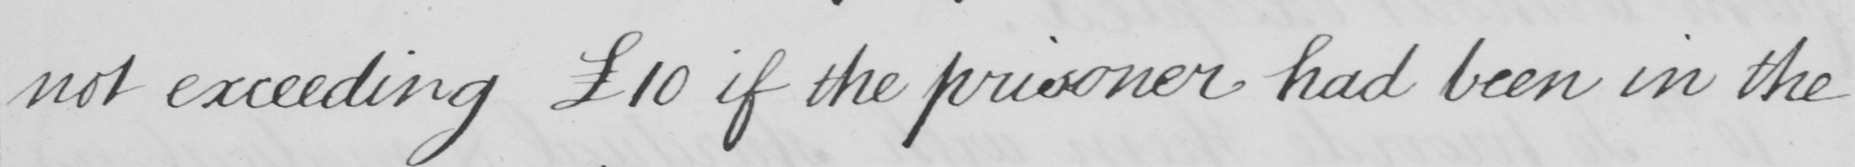Please provide the text content of this handwritten line. not exceeding £10 if the prisoner had been in the 